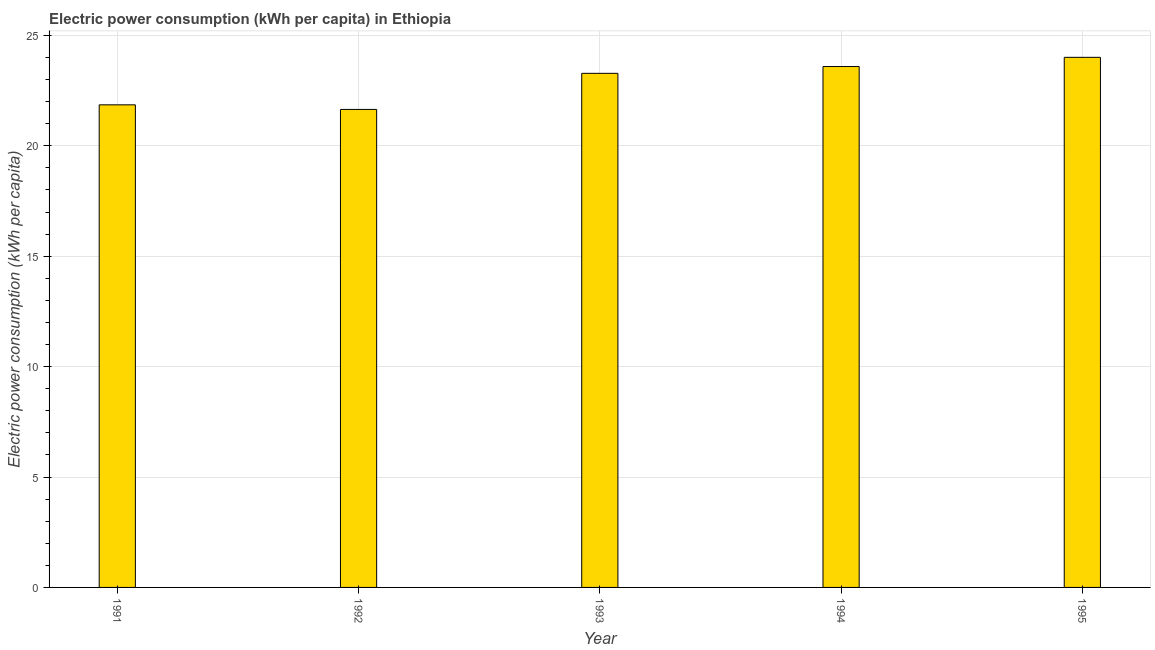Does the graph contain any zero values?
Give a very brief answer. No. What is the title of the graph?
Offer a very short reply. Electric power consumption (kWh per capita) in Ethiopia. What is the label or title of the X-axis?
Your response must be concise. Year. What is the label or title of the Y-axis?
Your answer should be compact. Electric power consumption (kWh per capita). What is the electric power consumption in 1991?
Provide a short and direct response. 21.85. Across all years, what is the maximum electric power consumption?
Make the answer very short. 24.01. Across all years, what is the minimum electric power consumption?
Offer a very short reply. 21.65. What is the sum of the electric power consumption?
Your response must be concise. 114.37. What is the difference between the electric power consumption in 1991 and 1993?
Offer a terse response. -1.43. What is the average electric power consumption per year?
Keep it short and to the point. 22.88. What is the median electric power consumption?
Provide a short and direct response. 23.28. In how many years, is the electric power consumption greater than 5 kWh per capita?
Keep it short and to the point. 5. Do a majority of the years between 1993 and 1992 (inclusive) have electric power consumption greater than 5 kWh per capita?
Provide a succinct answer. No. What is the ratio of the electric power consumption in 1991 to that in 1994?
Provide a short and direct response. 0.93. Is the electric power consumption in 1991 less than that in 1992?
Ensure brevity in your answer.  No. What is the difference between the highest and the second highest electric power consumption?
Ensure brevity in your answer.  0.42. What is the difference between the highest and the lowest electric power consumption?
Your response must be concise. 2.36. How many bars are there?
Your answer should be very brief. 5. How many years are there in the graph?
Offer a very short reply. 5. What is the difference between two consecutive major ticks on the Y-axis?
Provide a succinct answer. 5. Are the values on the major ticks of Y-axis written in scientific E-notation?
Keep it short and to the point. No. What is the Electric power consumption (kWh per capita) of 1991?
Your answer should be compact. 21.85. What is the Electric power consumption (kWh per capita) in 1992?
Offer a terse response. 21.65. What is the Electric power consumption (kWh per capita) in 1993?
Provide a succinct answer. 23.28. What is the Electric power consumption (kWh per capita) of 1994?
Your response must be concise. 23.59. What is the Electric power consumption (kWh per capita) of 1995?
Ensure brevity in your answer.  24.01. What is the difference between the Electric power consumption (kWh per capita) in 1991 and 1992?
Keep it short and to the point. 0.21. What is the difference between the Electric power consumption (kWh per capita) in 1991 and 1993?
Your response must be concise. -1.43. What is the difference between the Electric power consumption (kWh per capita) in 1991 and 1994?
Provide a short and direct response. -1.73. What is the difference between the Electric power consumption (kWh per capita) in 1991 and 1995?
Make the answer very short. -2.15. What is the difference between the Electric power consumption (kWh per capita) in 1992 and 1993?
Offer a terse response. -1.63. What is the difference between the Electric power consumption (kWh per capita) in 1992 and 1994?
Provide a succinct answer. -1.94. What is the difference between the Electric power consumption (kWh per capita) in 1992 and 1995?
Keep it short and to the point. -2.36. What is the difference between the Electric power consumption (kWh per capita) in 1993 and 1994?
Your answer should be very brief. -0.31. What is the difference between the Electric power consumption (kWh per capita) in 1993 and 1995?
Make the answer very short. -0.72. What is the difference between the Electric power consumption (kWh per capita) in 1994 and 1995?
Offer a terse response. -0.42. What is the ratio of the Electric power consumption (kWh per capita) in 1991 to that in 1993?
Make the answer very short. 0.94. What is the ratio of the Electric power consumption (kWh per capita) in 1991 to that in 1994?
Your answer should be compact. 0.93. What is the ratio of the Electric power consumption (kWh per capita) in 1991 to that in 1995?
Your answer should be compact. 0.91. What is the ratio of the Electric power consumption (kWh per capita) in 1992 to that in 1993?
Give a very brief answer. 0.93. What is the ratio of the Electric power consumption (kWh per capita) in 1992 to that in 1994?
Make the answer very short. 0.92. What is the ratio of the Electric power consumption (kWh per capita) in 1992 to that in 1995?
Make the answer very short. 0.9. What is the ratio of the Electric power consumption (kWh per capita) in 1994 to that in 1995?
Your response must be concise. 0.98. 